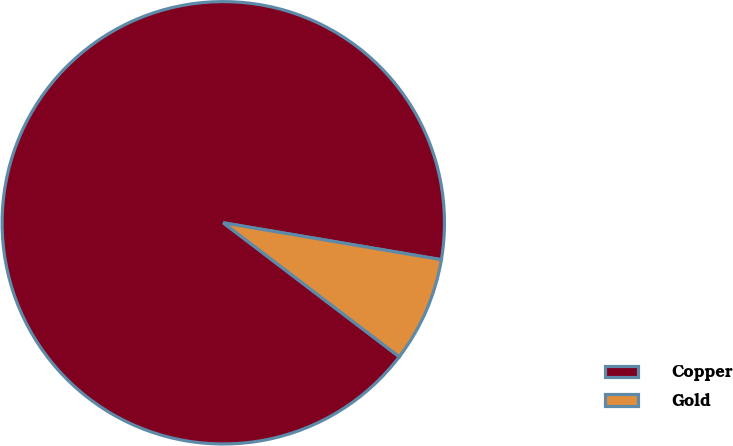<chart> <loc_0><loc_0><loc_500><loc_500><pie_chart><fcel>Copper<fcel>Gold<nl><fcel>92.31%<fcel>7.69%<nl></chart> 